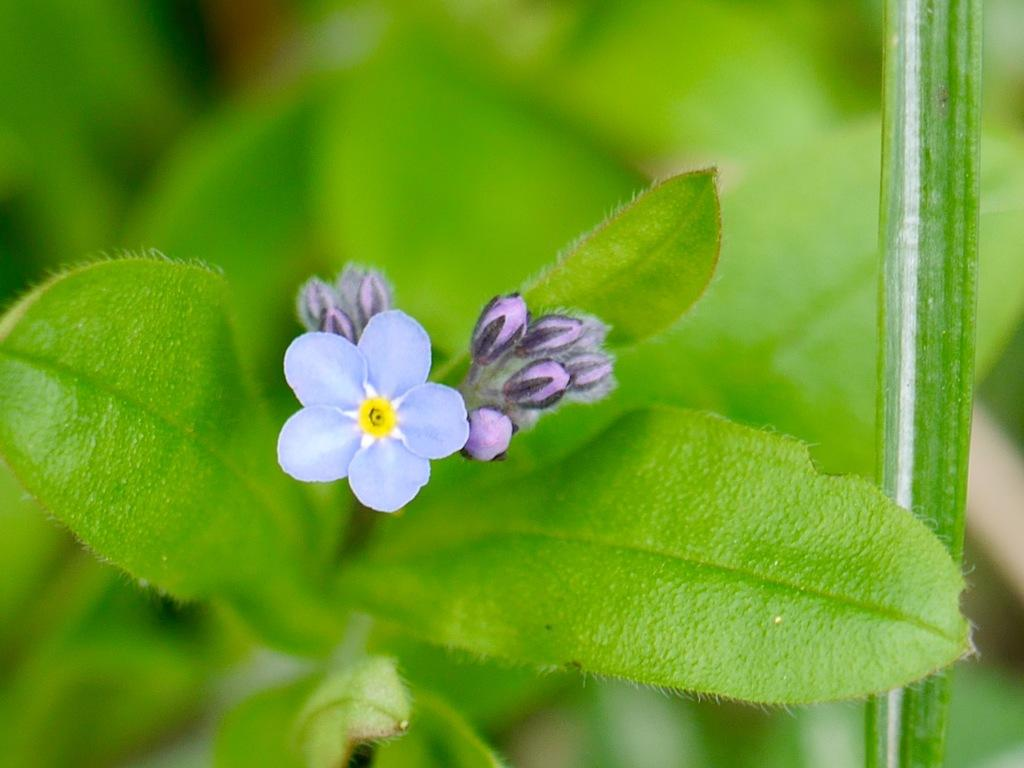What is located in the center of the image? There are plants and flowers in the center of the image. What specific type of plant or flower can be seen in the image? The image features plants and flowers, but it does not specify the exact type. What color are the plants and flowers in the image? The plants and flowers are in dark blue color. What type of reaction can be seen in the wound in the image? There is no wound present in the image; it features plants and flowers in dark blue color. 